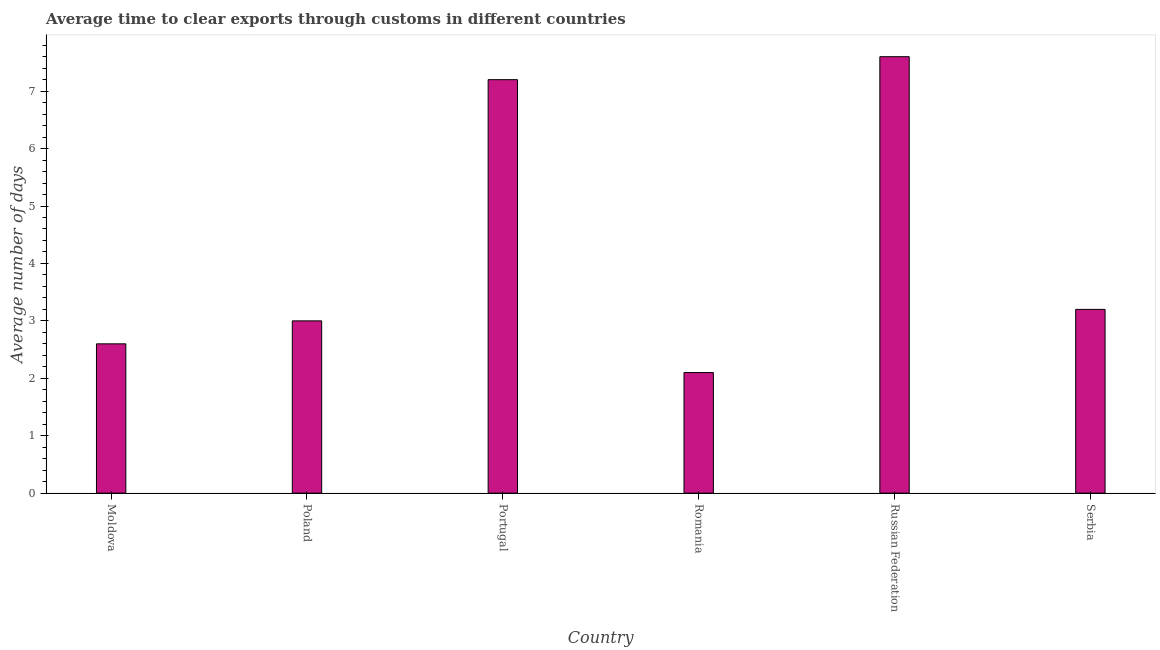Does the graph contain grids?
Give a very brief answer. No. What is the title of the graph?
Ensure brevity in your answer.  Average time to clear exports through customs in different countries. What is the label or title of the X-axis?
Your answer should be compact. Country. What is the label or title of the Y-axis?
Offer a very short reply. Average number of days. What is the time to clear exports through customs in Portugal?
Your response must be concise. 7.2. In which country was the time to clear exports through customs maximum?
Your answer should be compact. Russian Federation. In which country was the time to clear exports through customs minimum?
Your answer should be compact. Romania. What is the sum of the time to clear exports through customs?
Offer a very short reply. 25.7. What is the average time to clear exports through customs per country?
Provide a short and direct response. 4.28. What is the median time to clear exports through customs?
Offer a very short reply. 3.1. In how many countries, is the time to clear exports through customs greater than 0.6 days?
Offer a very short reply. 6. What is the ratio of the time to clear exports through customs in Russian Federation to that in Serbia?
Ensure brevity in your answer.  2.38. Is the time to clear exports through customs in Portugal less than that in Romania?
Ensure brevity in your answer.  No. Is the sum of the time to clear exports through customs in Poland and Portugal greater than the maximum time to clear exports through customs across all countries?
Give a very brief answer. Yes. What is the difference between the highest and the lowest time to clear exports through customs?
Offer a very short reply. 5.5. How many countries are there in the graph?
Provide a succinct answer. 6. What is the difference between two consecutive major ticks on the Y-axis?
Ensure brevity in your answer.  1. What is the Average number of days of Poland?
Offer a very short reply. 3. What is the difference between the Average number of days in Moldova and Portugal?
Offer a very short reply. -4.6. What is the difference between the Average number of days in Moldova and Romania?
Provide a short and direct response. 0.5. What is the difference between the Average number of days in Moldova and Serbia?
Provide a short and direct response. -0.6. What is the difference between the Average number of days in Poland and Russian Federation?
Your answer should be compact. -4.6. What is the difference between the Average number of days in Poland and Serbia?
Ensure brevity in your answer.  -0.2. What is the ratio of the Average number of days in Moldova to that in Poland?
Keep it short and to the point. 0.87. What is the ratio of the Average number of days in Moldova to that in Portugal?
Make the answer very short. 0.36. What is the ratio of the Average number of days in Moldova to that in Romania?
Provide a short and direct response. 1.24. What is the ratio of the Average number of days in Moldova to that in Russian Federation?
Offer a very short reply. 0.34. What is the ratio of the Average number of days in Moldova to that in Serbia?
Offer a very short reply. 0.81. What is the ratio of the Average number of days in Poland to that in Portugal?
Make the answer very short. 0.42. What is the ratio of the Average number of days in Poland to that in Romania?
Offer a terse response. 1.43. What is the ratio of the Average number of days in Poland to that in Russian Federation?
Ensure brevity in your answer.  0.4. What is the ratio of the Average number of days in Poland to that in Serbia?
Ensure brevity in your answer.  0.94. What is the ratio of the Average number of days in Portugal to that in Romania?
Make the answer very short. 3.43. What is the ratio of the Average number of days in Portugal to that in Russian Federation?
Offer a very short reply. 0.95. What is the ratio of the Average number of days in Portugal to that in Serbia?
Your response must be concise. 2.25. What is the ratio of the Average number of days in Romania to that in Russian Federation?
Ensure brevity in your answer.  0.28. What is the ratio of the Average number of days in Romania to that in Serbia?
Keep it short and to the point. 0.66. What is the ratio of the Average number of days in Russian Federation to that in Serbia?
Offer a very short reply. 2.38. 